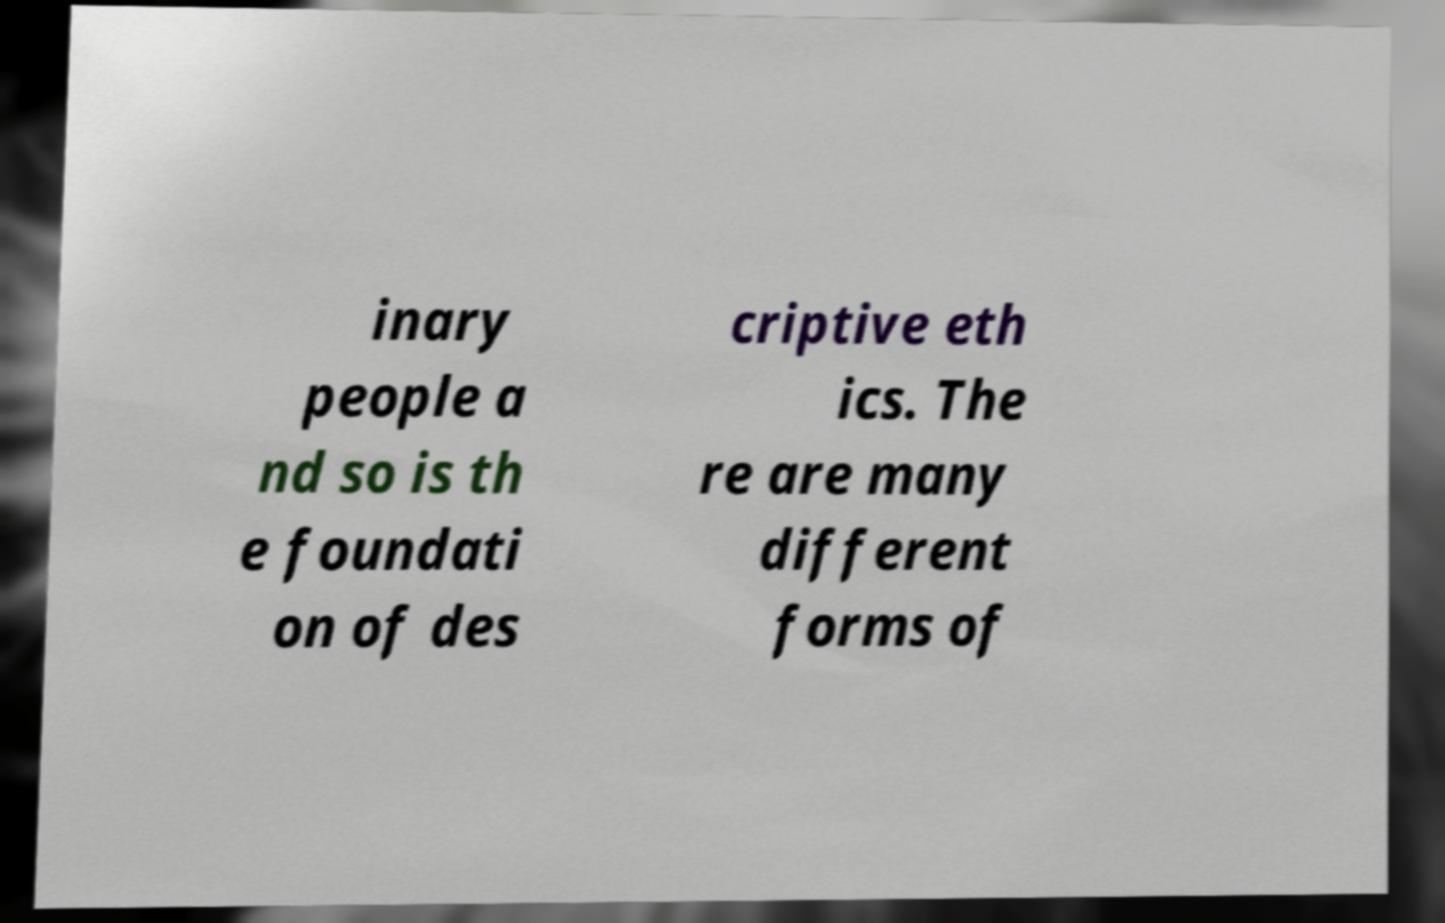Please read and relay the text visible in this image. What does it say? inary people a nd so is th e foundati on of des criptive eth ics. The re are many different forms of 